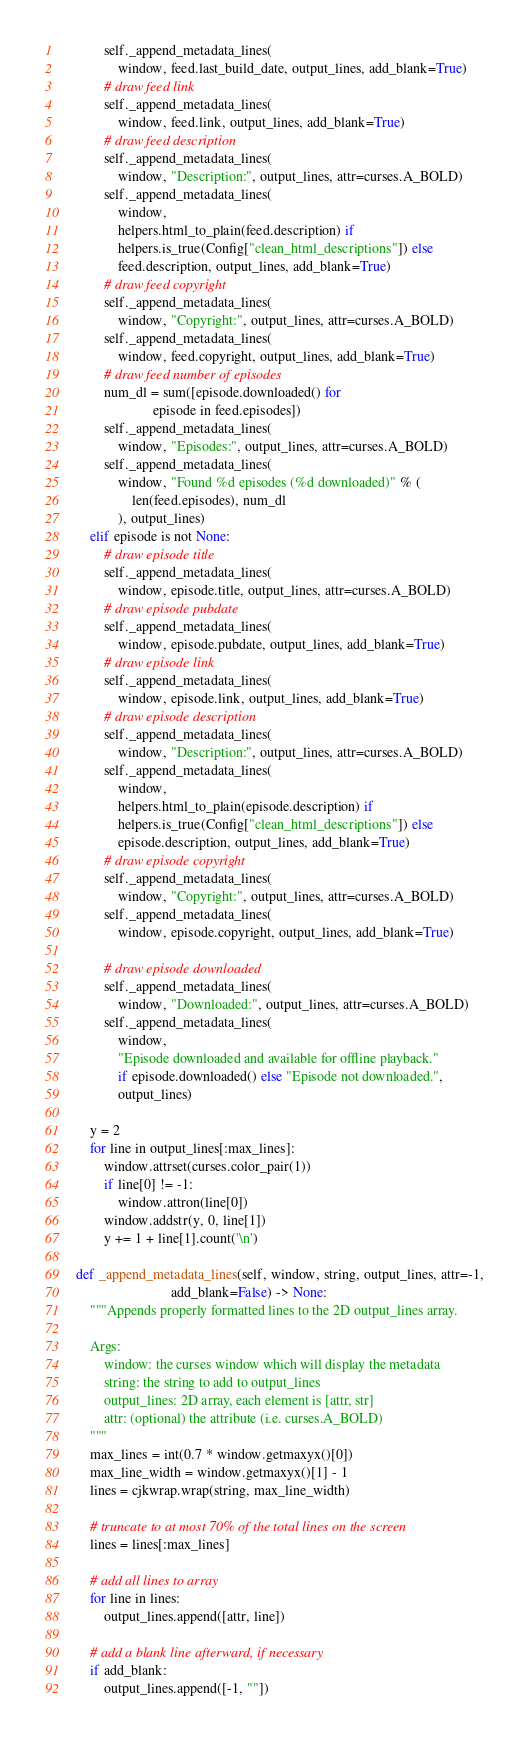<code> <loc_0><loc_0><loc_500><loc_500><_Python_>            self._append_metadata_lines(
                window, feed.last_build_date, output_lines, add_blank=True)
            # draw feed link
            self._append_metadata_lines(
                window, feed.link, output_lines, add_blank=True)
            # draw feed description
            self._append_metadata_lines(
                window, "Description:", output_lines, attr=curses.A_BOLD)
            self._append_metadata_lines(
                window,
                helpers.html_to_plain(feed.description) if
                helpers.is_true(Config["clean_html_descriptions"]) else
                feed.description, output_lines, add_blank=True)
            # draw feed copyright
            self._append_metadata_lines(
                window, "Copyright:", output_lines, attr=curses.A_BOLD)
            self._append_metadata_lines(
                window, feed.copyright, output_lines, add_blank=True)
            # draw feed number of episodes
            num_dl = sum([episode.downloaded() for
                          episode in feed.episodes])
            self._append_metadata_lines(
                window, "Episodes:", output_lines, attr=curses.A_BOLD)
            self._append_metadata_lines(
                window, "Found %d episodes (%d downloaded)" % (
                    len(feed.episodes), num_dl
                ), output_lines)
        elif episode is not None:
            # draw episode title
            self._append_metadata_lines(
                window, episode.title, output_lines, attr=curses.A_BOLD)
            # draw episode pubdate
            self._append_metadata_lines(
                window, episode.pubdate, output_lines, add_blank=True)
            # draw episode link
            self._append_metadata_lines(
                window, episode.link, output_lines, add_blank=True)
            # draw episode description
            self._append_metadata_lines(
                window, "Description:", output_lines, attr=curses.A_BOLD)
            self._append_metadata_lines(
                window,
                helpers.html_to_plain(episode.description) if
                helpers.is_true(Config["clean_html_descriptions"]) else
                episode.description, output_lines, add_blank=True)
            # draw episode copyright
            self._append_metadata_lines(
                window, "Copyright:", output_lines, attr=curses.A_BOLD)
            self._append_metadata_lines(
                window, episode.copyright, output_lines, add_blank=True)

            # draw episode downloaded
            self._append_metadata_lines(
                window, "Downloaded:", output_lines, attr=curses.A_BOLD)
            self._append_metadata_lines(
                window,
                "Episode downloaded and available for offline playback."
                if episode.downloaded() else "Episode not downloaded.",
                output_lines)

        y = 2
        for line in output_lines[:max_lines]:
            window.attrset(curses.color_pair(1))
            if line[0] != -1:
                window.attron(line[0])
            window.addstr(y, 0, line[1])
            y += 1 + line[1].count('\n')

    def _append_metadata_lines(self, window, string, output_lines, attr=-1,
                               add_blank=False) -> None:
        """Appends properly formatted lines to the 2D output_lines array.

        Args:
            window: the curses window which will display the metadata
            string: the string to add to output_lines
            output_lines: 2D array, each element is [attr, str]
            attr: (optional) the attribute (i.e. curses.A_BOLD)
        """
        max_lines = int(0.7 * window.getmaxyx()[0])
        max_line_width = window.getmaxyx()[1] - 1
        lines = cjkwrap.wrap(string, max_line_width)

        # truncate to at most 70% of the total lines on the screen
        lines = lines[:max_lines]

        # add all lines to array
        for line in lines:
            output_lines.append([attr, line])

        # add a blank line afterward, if necessary
        if add_blank:
            output_lines.append([-1, ""])
</code> 